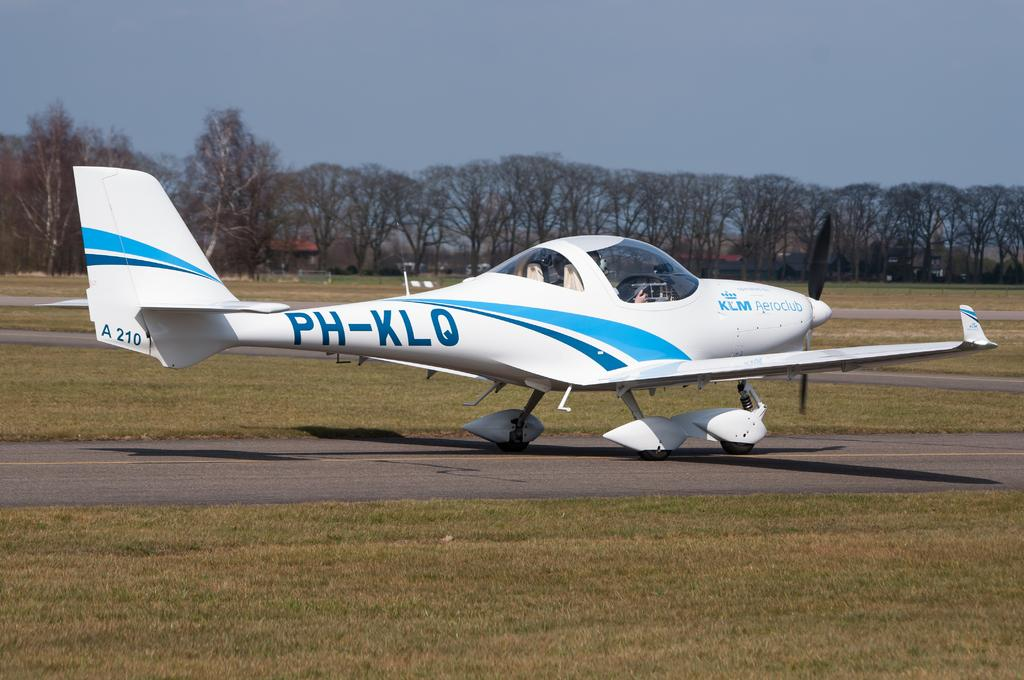What color is the aircraft in the image? The aircraft is white in the image. What is the position of the aircraft in the image? The aircraft appears to be parked on the ground in the image. What type of vegetation can be seen in the image? There is grass visible in the image. What is visible in the background of the image? The sky and trees are visible in the background of the image. Can you describe any other objects in the background of the image? There are other unspecified objects in the background of the image. Is there any indication of a fire or smoke in the image? No, there is no fire or smoke visible in the image. 